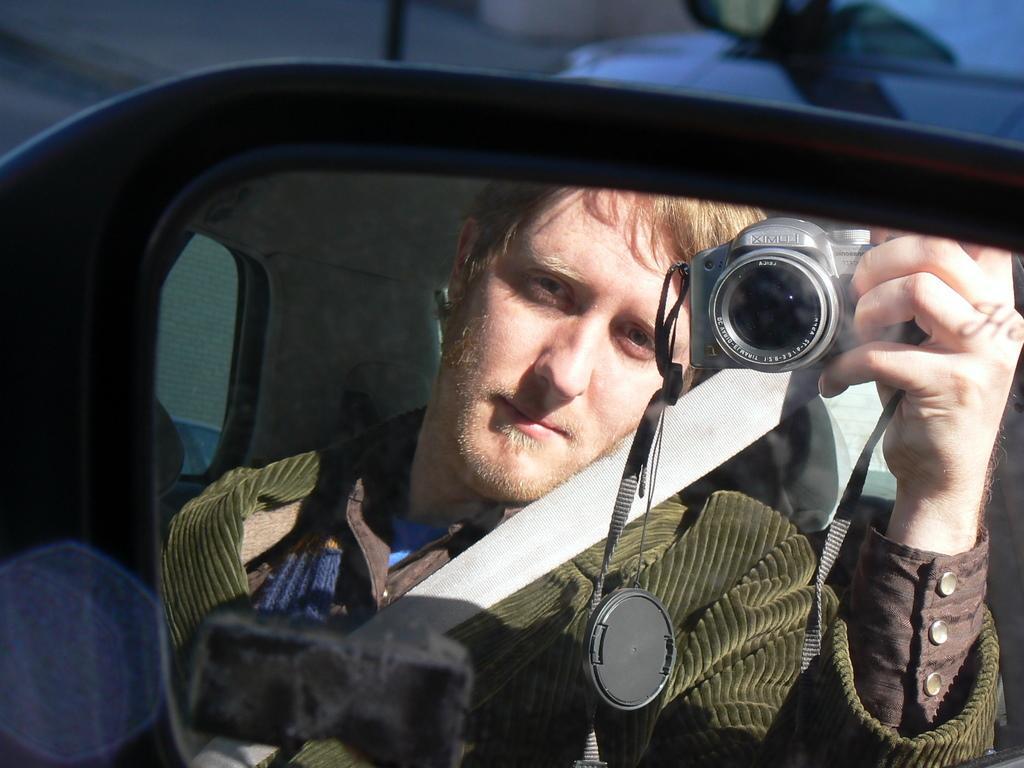Describe this image in one or two sentences. In the image I can see a person is sitting in a vehicle and holding a camera in the hand. The background of the image is blurred. 